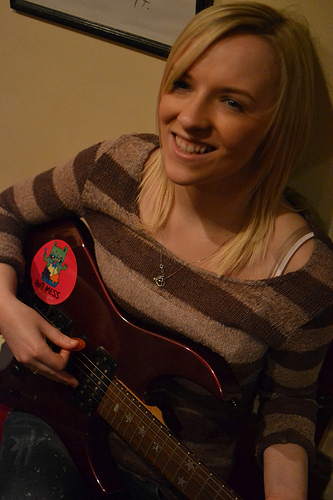<image>
Is there a sticker on the guitar? Yes. Looking at the image, I can see the sticker is positioned on top of the guitar, with the guitar providing support. Where is the sticker in relation to the guitar? Is it to the left of the guitar? No. The sticker is not to the left of the guitar. From this viewpoint, they have a different horizontal relationship. 